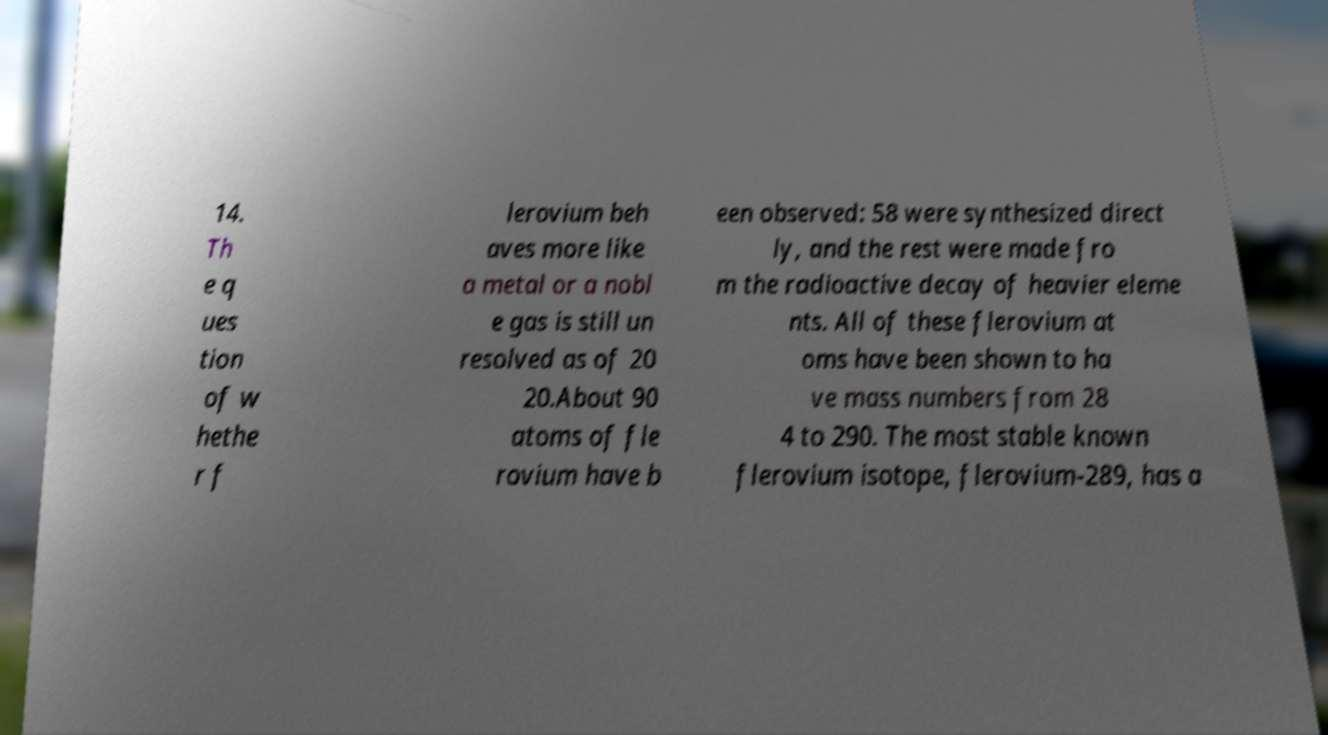Please read and relay the text visible in this image. What does it say? 14. Th e q ues tion of w hethe r f lerovium beh aves more like a metal or a nobl e gas is still un resolved as of 20 20.About 90 atoms of fle rovium have b een observed: 58 were synthesized direct ly, and the rest were made fro m the radioactive decay of heavier eleme nts. All of these flerovium at oms have been shown to ha ve mass numbers from 28 4 to 290. The most stable known flerovium isotope, flerovium-289, has a 